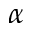Convert formula to latex. <formula><loc_0><loc_0><loc_500><loc_500>\alpha</formula> 